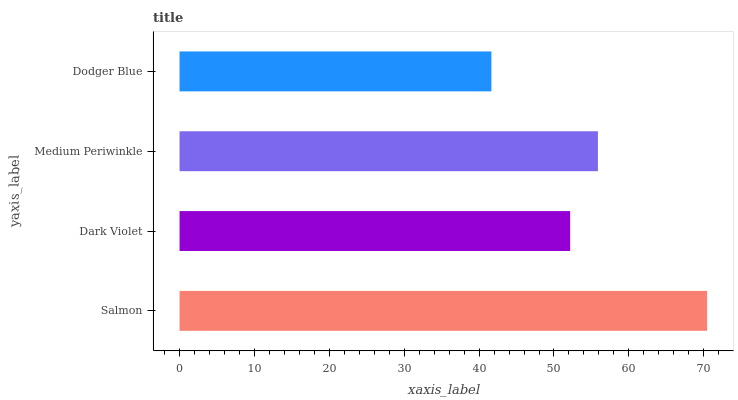Is Dodger Blue the minimum?
Answer yes or no. Yes. Is Salmon the maximum?
Answer yes or no. Yes. Is Dark Violet the minimum?
Answer yes or no. No. Is Dark Violet the maximum?
Answer yes or no. No. Is Salmon greater than Dark Violet?
Answer yes or no. Yes. Is Dark Violet less than Salmon?
Answer yes or no. Yes. Is Dark Violet greater than Salmon?
Answer yes or no. No. Is Salmon less than Dark Violet?
Answer yes or no. No. Is Medium Periwinkle the high median?
Answer yes or no. Yes. Is Dark Violet the low median?
Answer yes or no. Yes. Is Salmon the high median?
Answer yes or no. No. Is Salmon the low median?
Answer yes or no. No. 